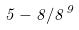Convert formula to latex. <formula><loc_0><loc_0><loc_500><loc_500>5 - 8 / 8 ^ { 9 }</formula> 